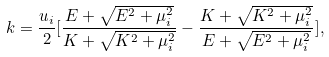<formula> <loc_0><loc_0><loc_500><loc_500>k = \frac { u _ { i } } { 2 } [ \frac { E + \sqrt { E ^ { 2 } + \mu _ { i } ^ { 2 } } } { K + \sqrt { K ^ { 2 } + \mu _ { i } ^ { 2 } } } - \frac { K + \sqrt { K ^ { 2 } + \mu _ { i } ^ { 2 } } } { E + \sqrt { E ^ { 2 } + \mu _ { i } ^ { 2 } } } ] ,</formula> 